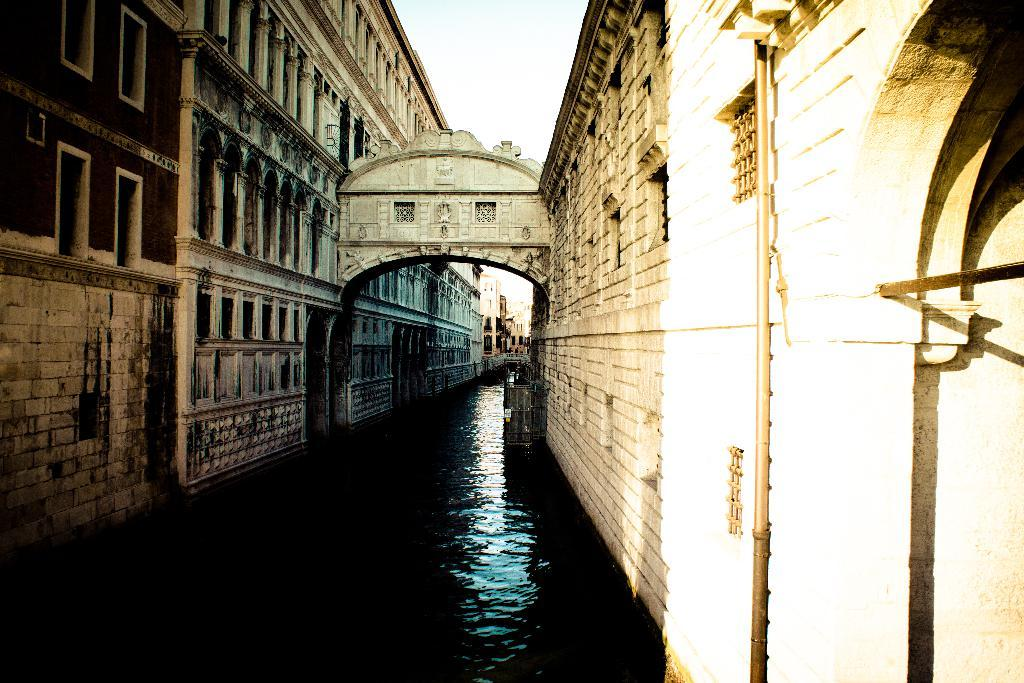What is the primary element visible in the image? There is water in the image. What structures can be seen near the water? There are buildings on either side of the water. What type of lace can be seen on the buildings in the image? There is no lace visible on the buildings in the image. 